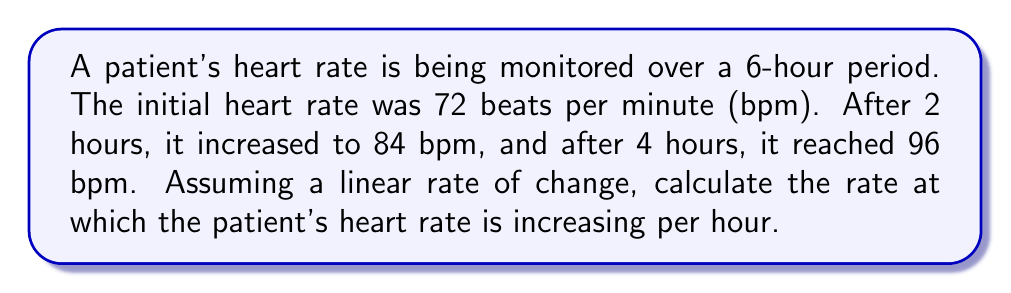Teach me how to tackle this problem. Let's approach this step-by-step:

1) First, we need to identify the change in heart rate over time:
   Initial rate: 72 bpm
   Rate after 4 hours: 96 bpm
   Total change: 96 - 72 = 24 bpm

2) Now, we need to determine the time period over which this change occurred:
   Time period: 4 hours

3) To calculate the rate of change, we use the formula:
   $$\text{Rate of change} = \frac{\text{Change in quantity}}{\text{Change in time}}$$

4) Plugging in our values:
   $$\text{Rate of change} = \frac{24 \text{ bpm}}{4 \text{ hours}} = 6 \text{ bpm/hour}$$

5) We can verify this by checking the intermediate point:
   After 2 hours, the rate should have increased by: 2 * 6 = 12 bpm
   72 + 12 = 84 bpm, which matches the given information

Therefore, the patient's heart rate is increasing at a rate of 6 beats per minute per hour.
Answer: 6 bpm/hour 